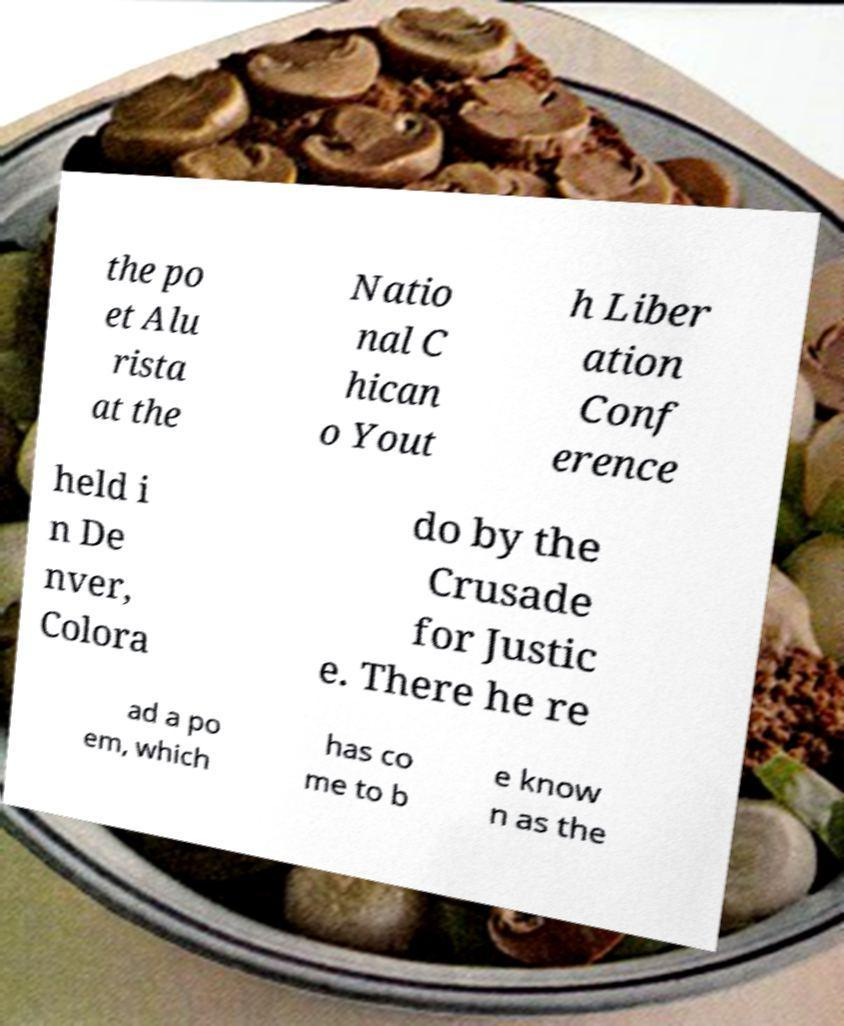Please read and relay the text visible in this image. What does it say? the po et Alu rista at the Natio nal C hican o Yout h Liber ation Conf erence held i n De nver, Colora do by the Crusade for Justic e. There he re ad a po em, which has co me to b e know n as the 